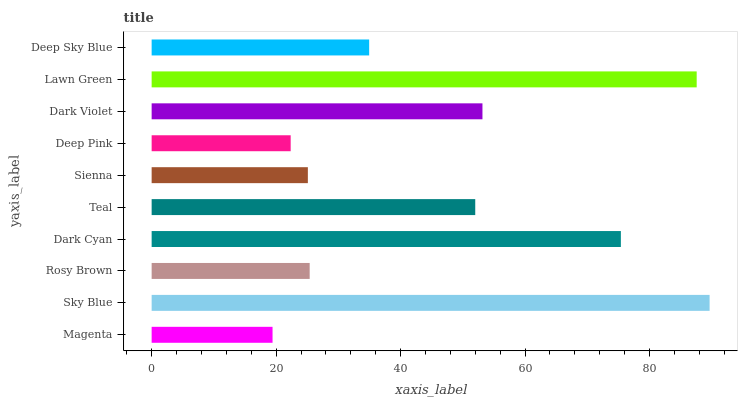Is Magenta the minimum?
Answer yes or no. Yes. Is Sky Blue the maximum?
Answer yes or no. Yes. Is Rosy Brown the minimum?
Answer yes or no. No. Is Rosy Brown the maximum?
Answer yes or no. No. Is Sky Blue greater than Rosy Brown?
Answer yes or no. Yes. Is Rosy Brown less than Sky Blue?
Answer yes or no. Yes. Is Rosy Brown greater than Sky Blue?
Answer yes or no. No. Is Sky Blue less than Rosy Brown?
Answer yes or no. No. Is Teal the high median?
Answer yes or no. Yes. Is Deep Sky Blue the low median?
Answer yes or no. Yes. Is Lawn Green the high median?
Answer yes or no. No. Is Sky Blue the low median?
Answer yes or no. No. 